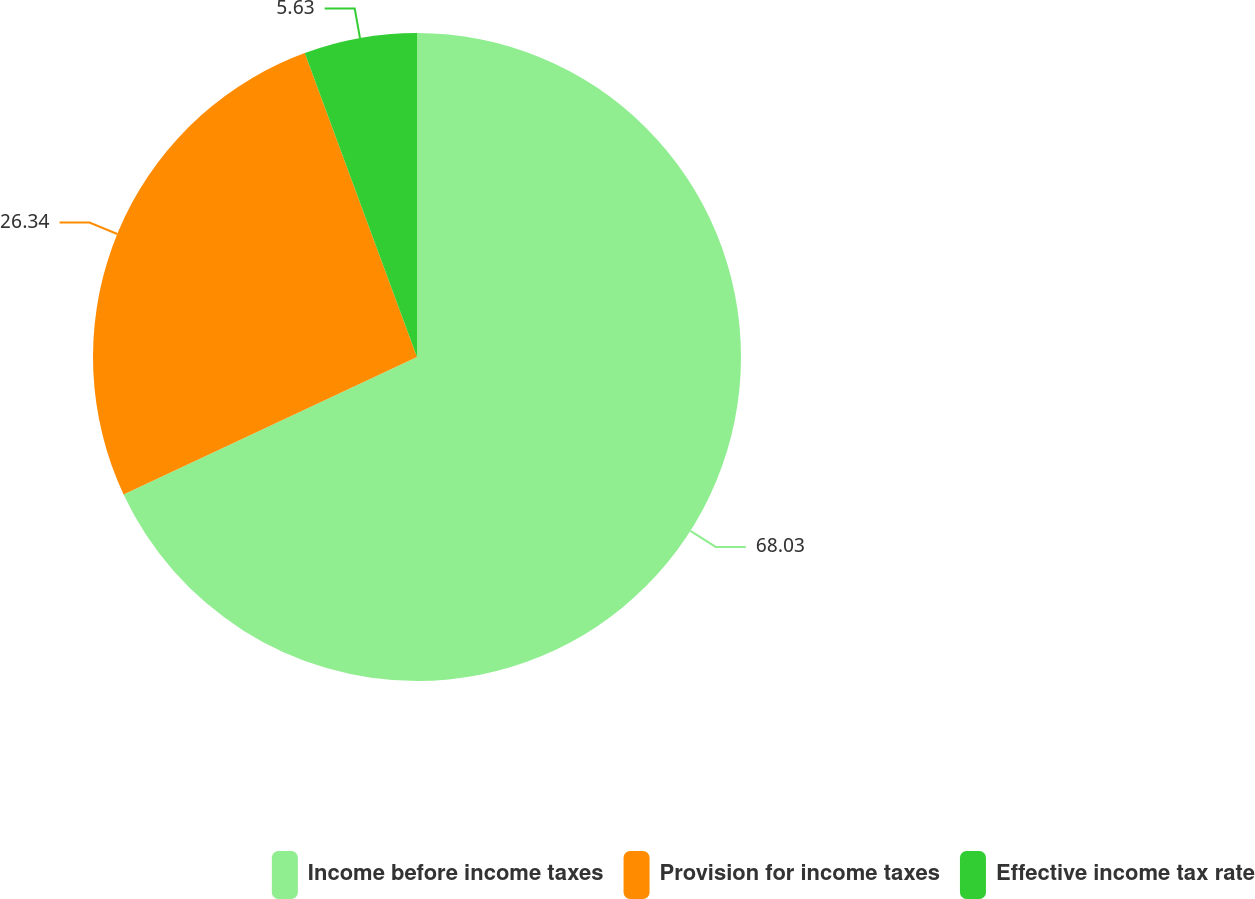<chart> <loc_0><loc_0><loc_500><loc_500><pie_chart><fcel>Income before income taxes<fcel>Provision for income taxes<fcel>Effective income tax rate<nl><fcel>68.03%<fcel>26.34%<fcel>5.63%<nl></chart> 